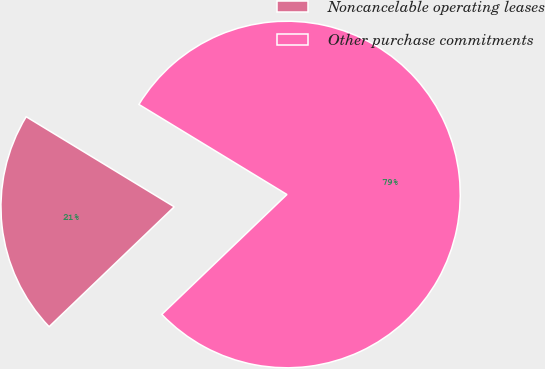Convert chart. <chart><loc_0><loc_0><loc_500><loc_500><pie_chart><fcel>Noncancelable operating leases<fcel>Other purchase commitments<nl><fcel>20.86%<fcel>79.14%<nl></chart> 